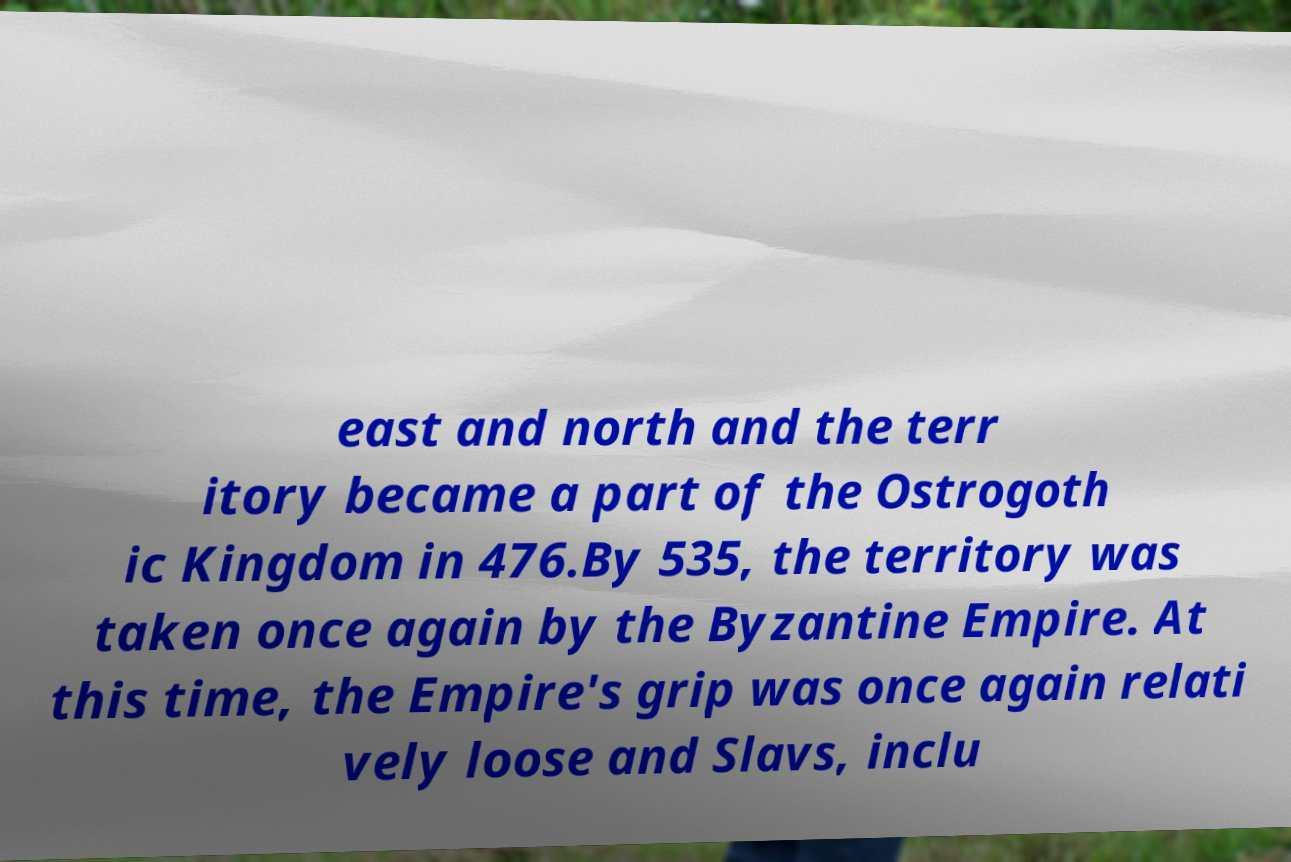There's text embedded in this image that I need extracted. Can you transcribe it verbatim? east and north and the terr itory became a part of the Ostrogoth ic Kingdom in 476.By 535, the territory was taken once again by the Byzantine Empire. At this time, the Empire's grip was once again relati vely loose and Slavs, inclu 